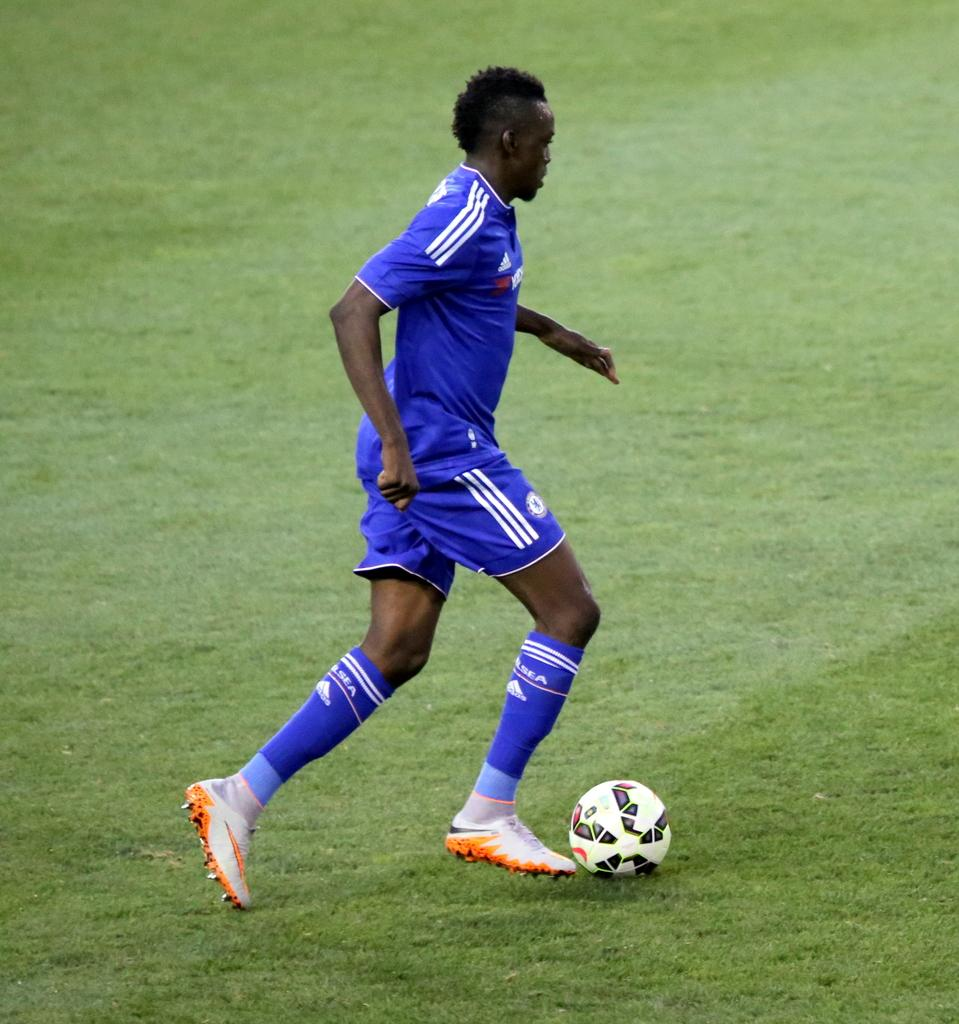What is the person in the image doing? The person is playing football. What surface is the football being played on? The football is being played on the ground. What type of thread is being used to sew the ship in the image? There is no ship present in the image, and therefore no thread being used to sew it. 